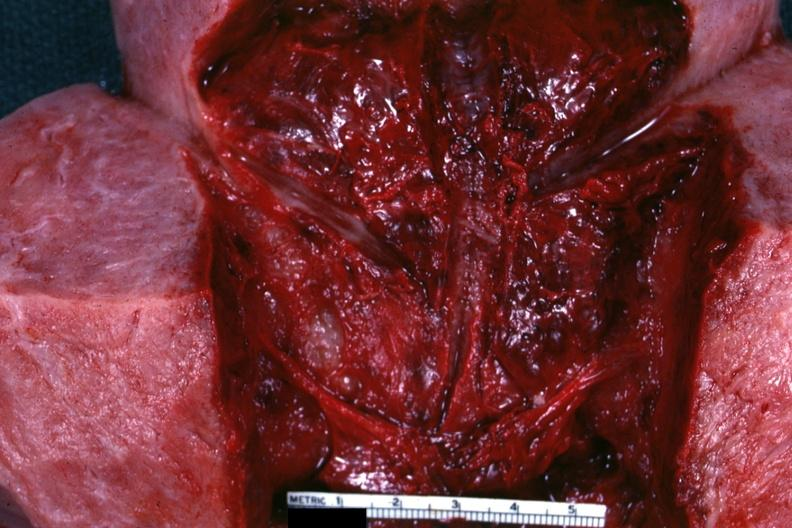when does this image show close-up view of endometrial surface 18 hours?
Answer the question using a single word or phrase. After a cesarean section 